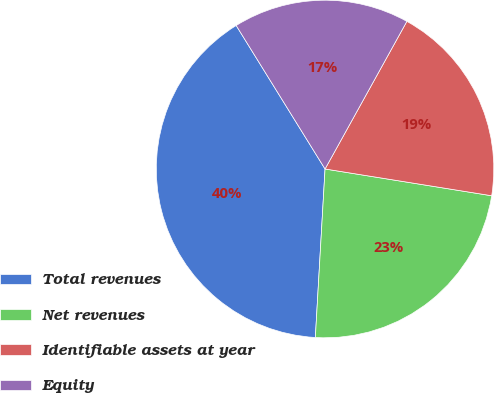<chart> <loc_0><loc_0><loc_500><loc_500><pie_chart><fcel>Total revenues<fcel>Net revenues<fcel>Identifiable assets at year<fcel>Equity<nl><fcel>40.26%<fcel>23.38%<fcel>19.48%<fcel>16.88%<nl></chart> 